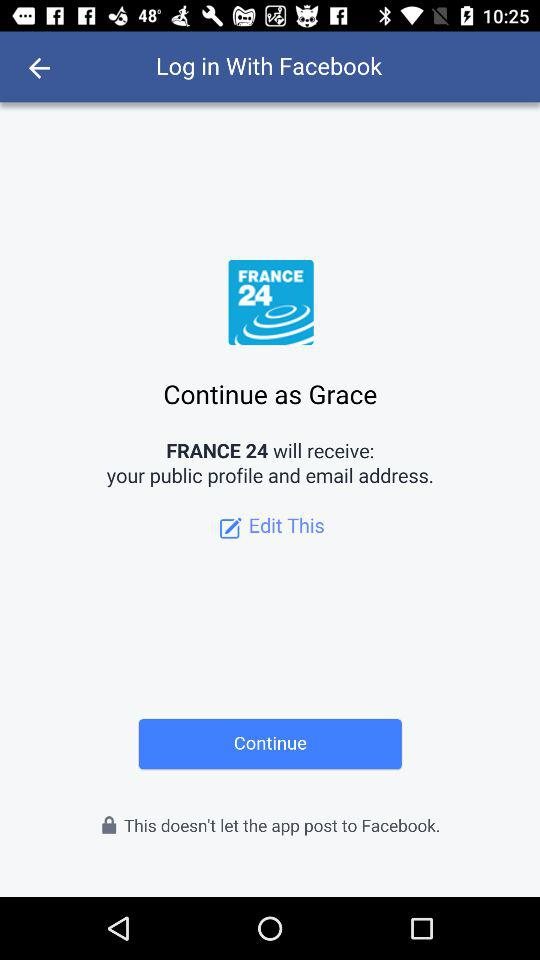What is the application name? The application name is "FRANCE 24". 